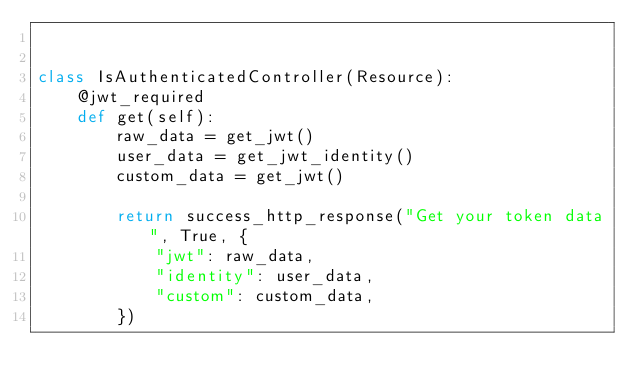Convert code to text. <code><loc_0><loc_0><loc_500><loc_500><_Python_>

class IsAuthenticatedController(Resource):
    @jwt_required
    def get(self):
        raw_data = get_jwt()
        user_data = get_jwt_identity()
        custom_data = get_jwt()

        return success_http_response("Get your token data", True, {
            "jwt": raw_data,
            "identity": user_data,
            "custom": custom_data,
        })
</code> 